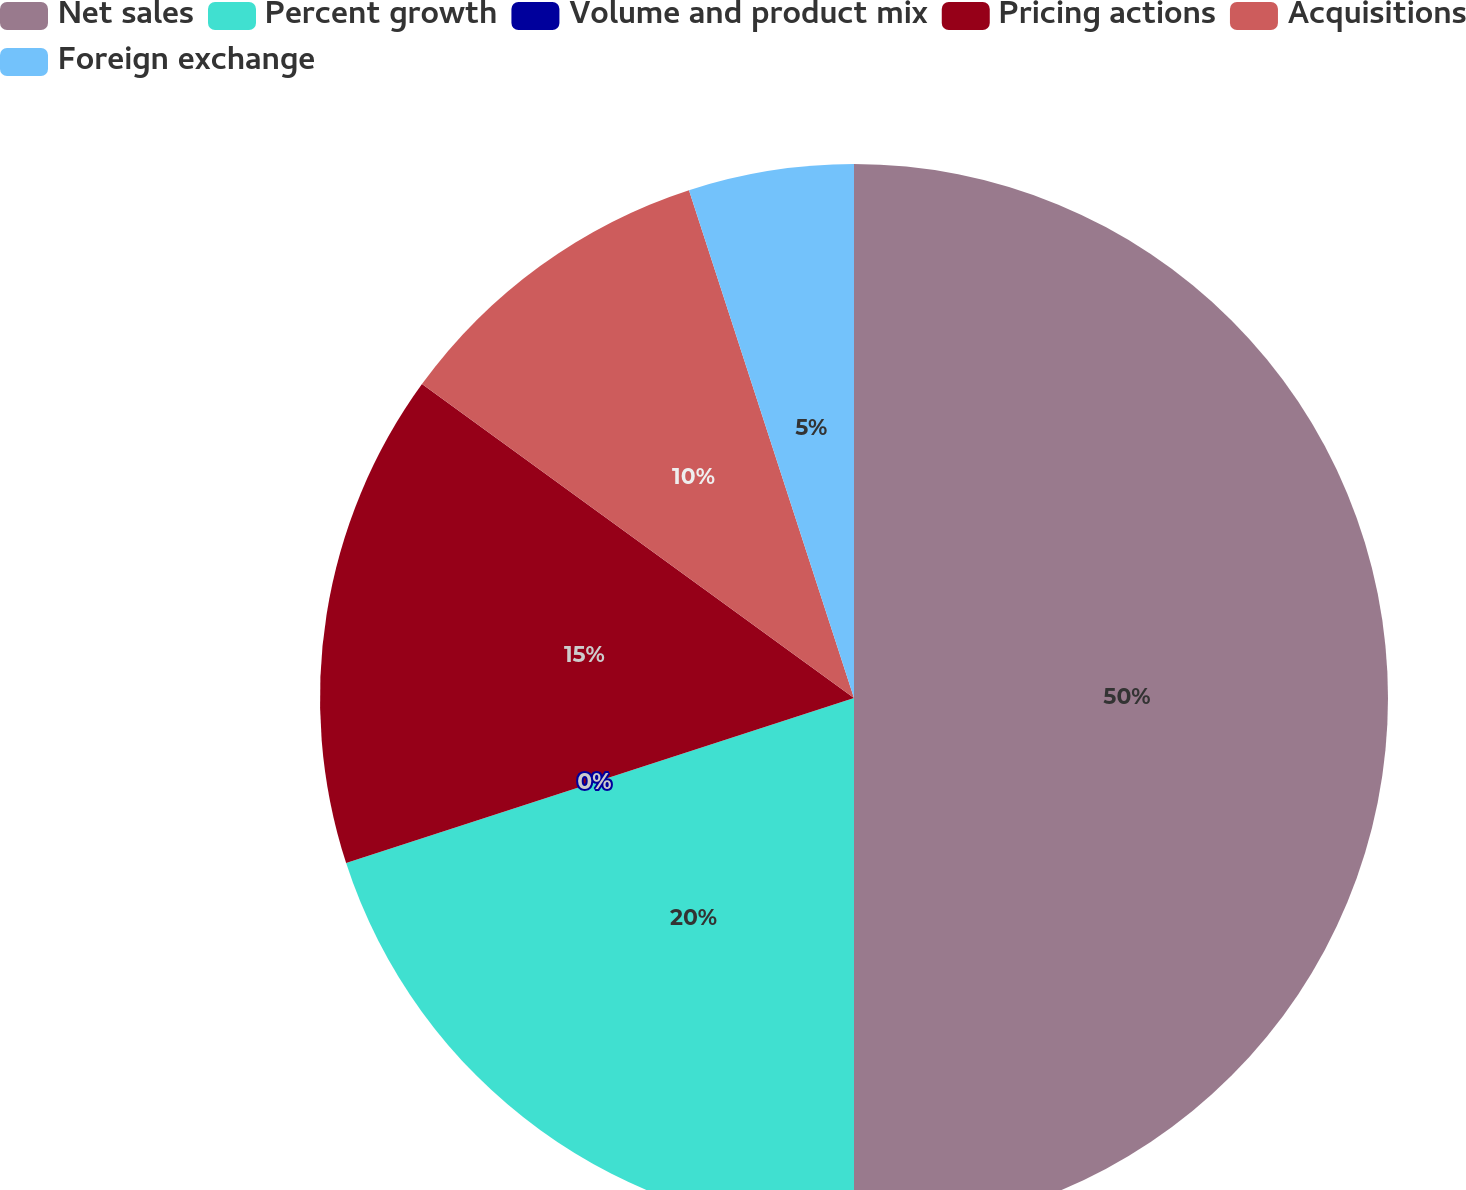<chart> <loc_0><loc_0><loc_500><loc_500><pie_chart><fcel>Net sales<fcel>Percent growth<fcel>Volume and product mix<fcel>Pricing actions<fcel>Acquisitions<fcel>Foreign exchange<nl><fcel>50.0%<fcel>20.0%<fcel>0.0%<fcel>15.0%<fcel>10.0%<fcel>5.0%<nl></chart> 